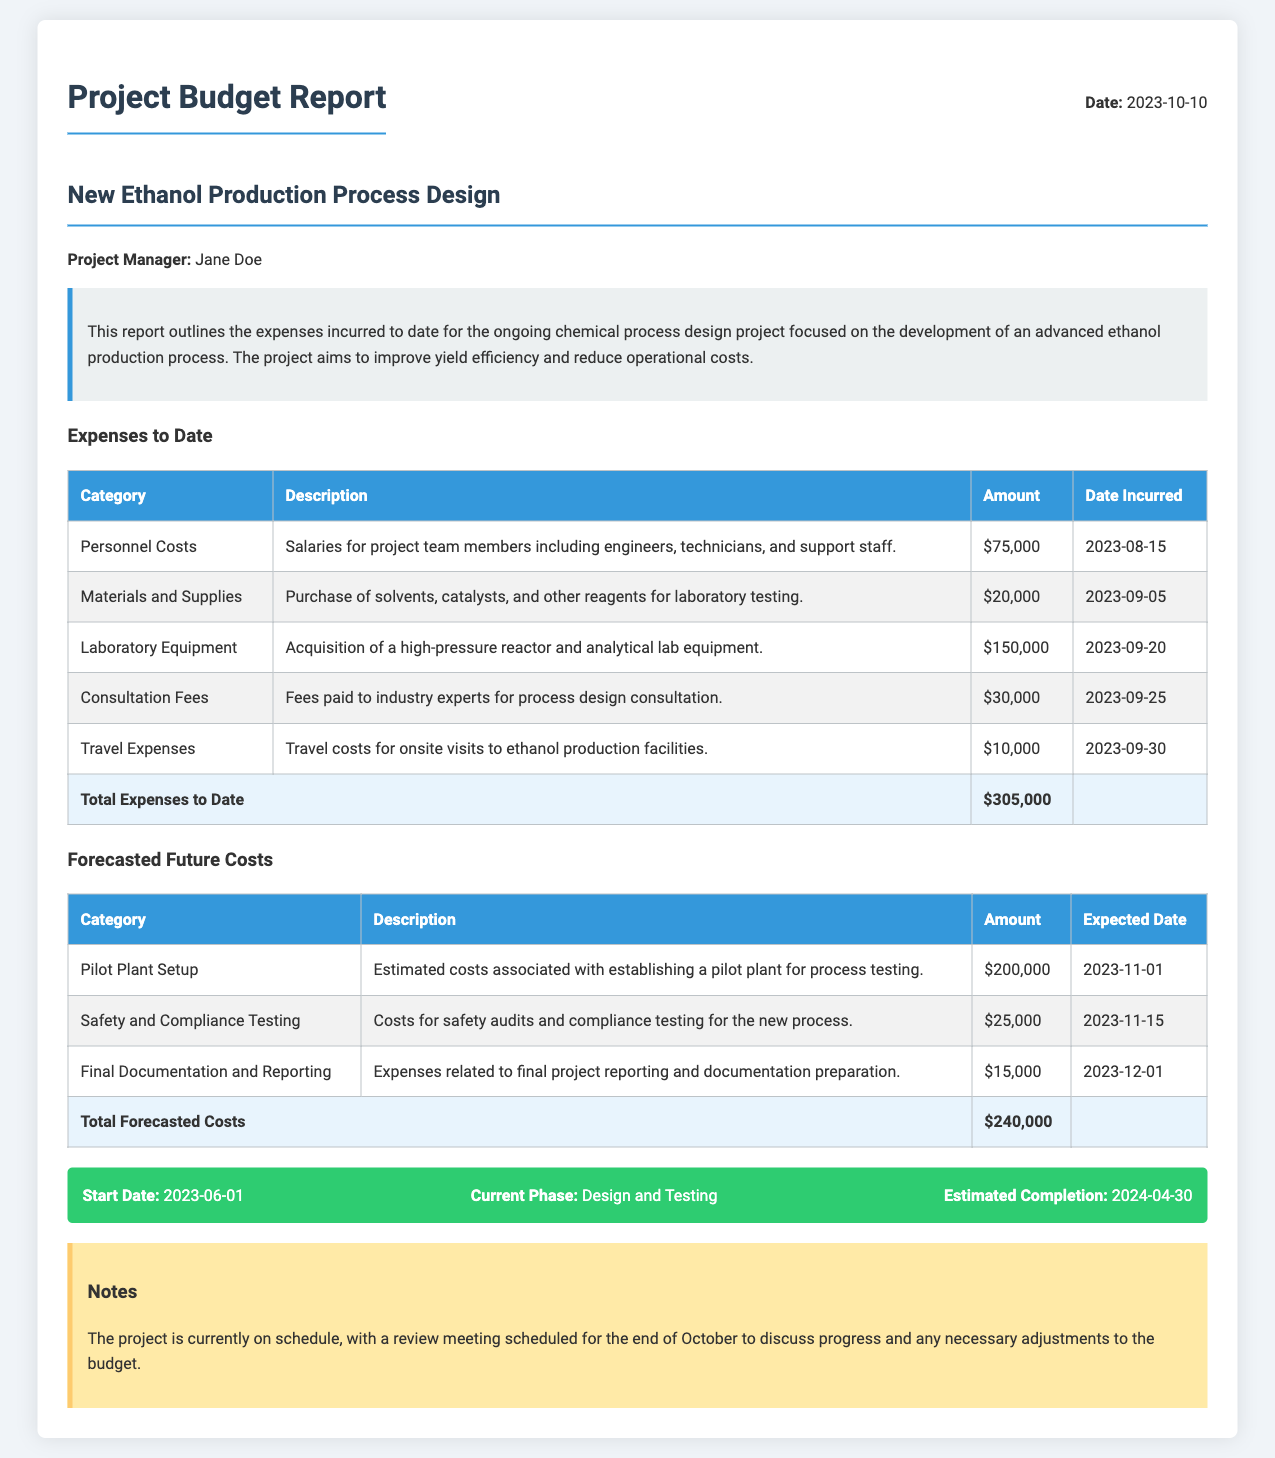What is the total amount of expenses incurred to date? The total expenses to date is listed in the document under the "Total Expenses to Date" row, which shows $305,000.
Answer: $305,000 Who is the project manager? The project manager's name is provided in the document, specifically mentioned as Jane Doe.
Answer: Jane Doe What is the expected date for the Pilot Plant Setup? The expected date for the Pilot Plant Setup is found in the "Forecasted Future Costs" section, showing November 1, 2023.
Answer: 2023-11-01 How much is allocated for Safety and Compliance Testing? The amount allocated for Safety and Compliance Testing is specifically listed in the table under "Forecasted Future Costs" as $25,000.
Answer: $25,000 What is the current phase of the project? The current phase of the project is explicitly mentioned in the timeline section, which states "Design and Testing."
Answer: Design and Testing What category incurred the highest expense to date? The category with the highest expense is "Laboratory Equipment," with a total of $150,000 recorded in the expenses table.
Answer: Laboratory Equipment What is the completion date for this project? The estimated completion date is outlined in the timeline information, indicated as April 30, 2024.
Answer: 2024-04-30 How much will the final documentation and reporting cost? The document specifies that the cost for final documentation and reporting is $15,000, as indicated in the corresponding table.
Answer: $15,000 What is the total forecasted cost for the project? The total forecasted costs are summarized in a row labeled "Total Forecasted Costs" which shows a total of $240,000.
Answer: $240,000 